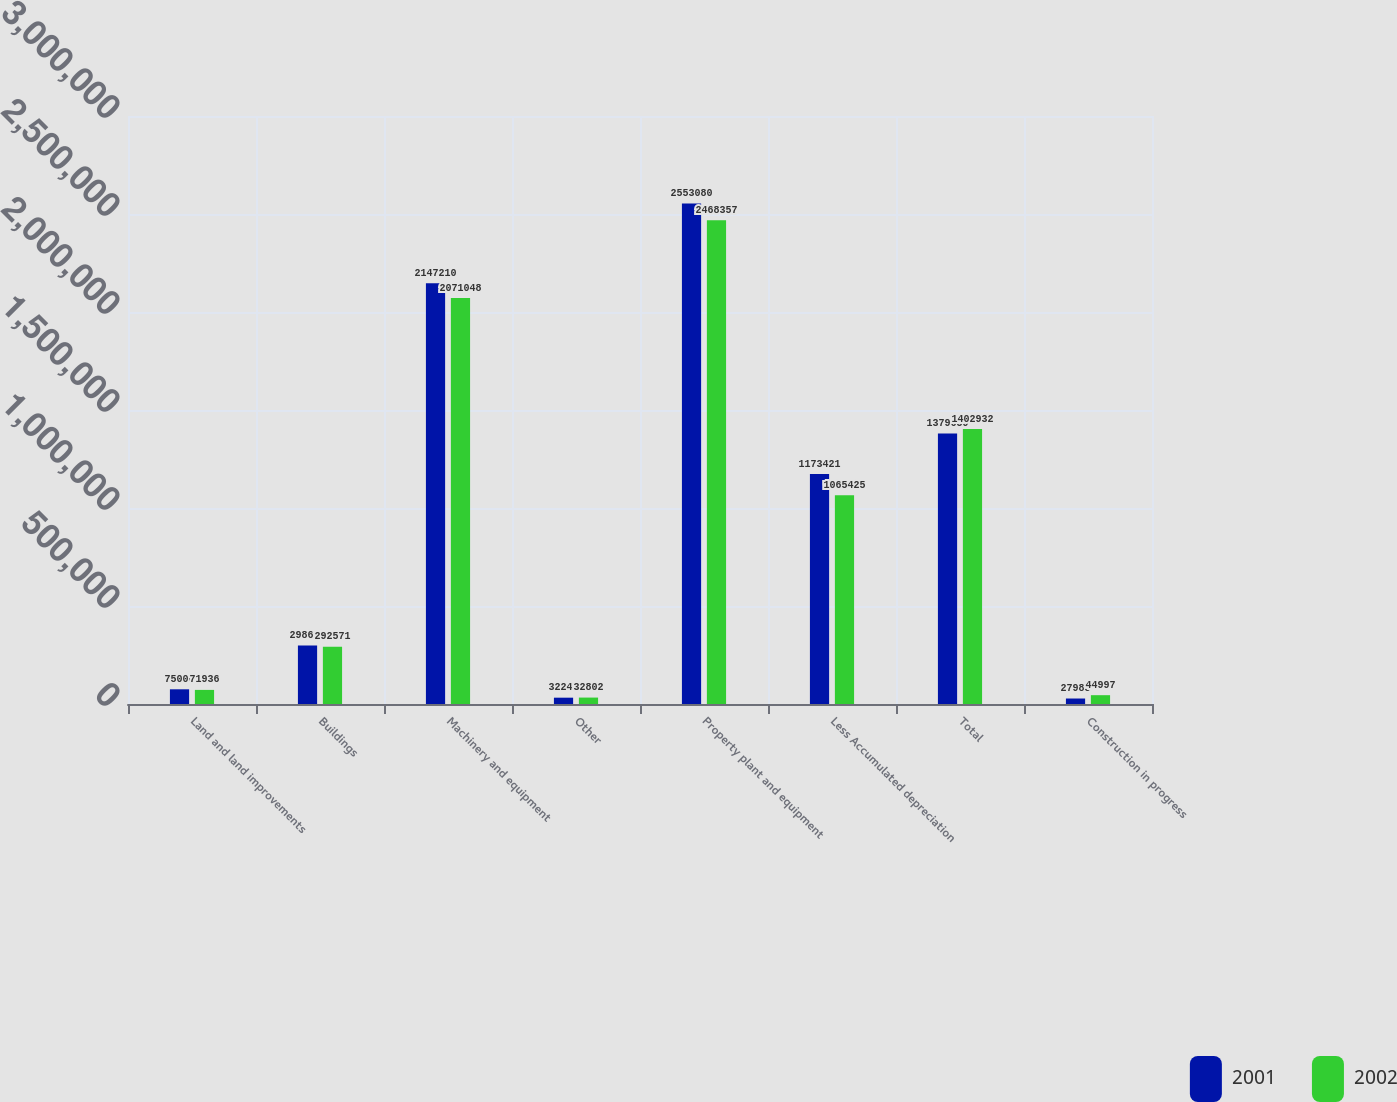Convert chart. <chart><loc_0><loc_0><loc_500><loc_500><stacked_bar_chart><ecel><fcel>Land and land improvements<fcel>Buildings<fcel>Machinery and equipment<fcel>Other<fcel>Property plant and equipment<fcel>Less Accumulated depreciation<fcel>Total<fcel>Construction in progress<nl><fcel>2001<fcel>75006<fcel>298616<fcel>2.14721e+06<fcel>32248<fcel>2.55308e+06<fcel>1.17342e+06<fcel>1.37966e+06<fcel>27985<nl><fcel>2002<fcel>71936<fcel>292571<fcel>2.07105e+06<fcel>32802<fcel>2.46836e+06<fcel>1.06542e+06<fcel>1.40293e+06<fcel>44997<nl></chart> 